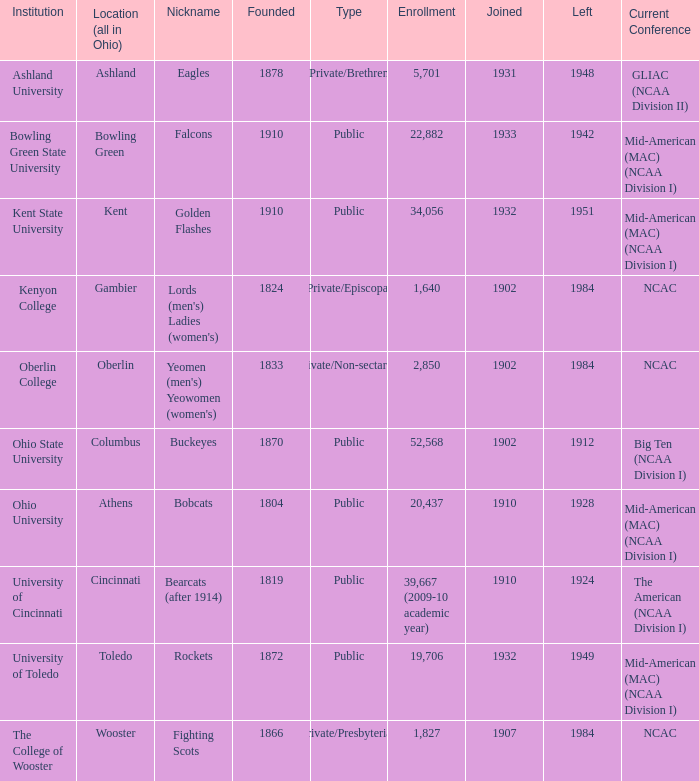What is the type of institution in Kent State University? Public. 